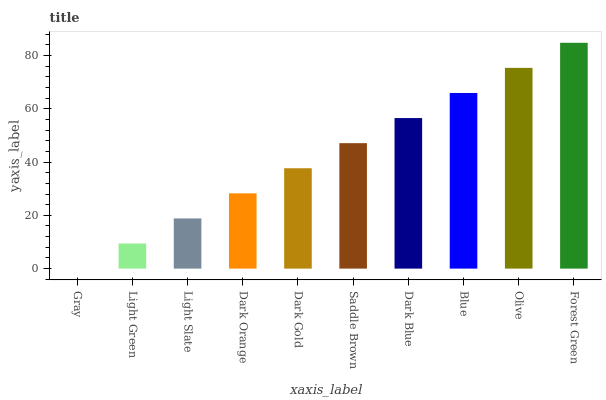Is Light Green the minimum?
Answer yes or no. No. Is Light Green the maximum?
Answer yes or no. No. Is Light Green greater than Gray?
Answer yes or no. Yes. Is Gray less than Light Green?
Answer yes or no. Yes. Is Gray greater than Light Green?
Answer yes or no. No. Is Light Green less than Gray?
Answer yes or no. No. Is Saddle Brown the high median?
Answer yes or no. Yes. Is Dark Gold the low median?
Answer yes or no. Yes. Is Dark Orange the high median?
Answer yes or no. No. Is Dark Orange the low median?
Answer yes or no. No. 